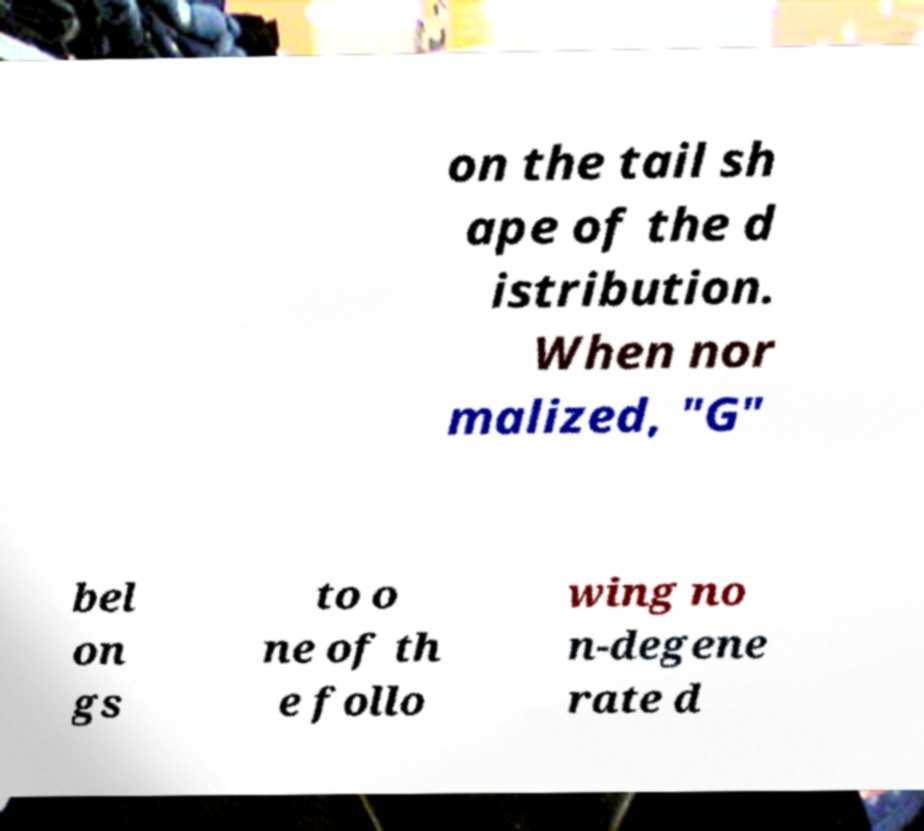Please identify and transcribe the text found in this image. on the tail sh ape of the d istribution. When nor malized, "G" bel on gs to o ne of th e follo wing no n-degene rate d 